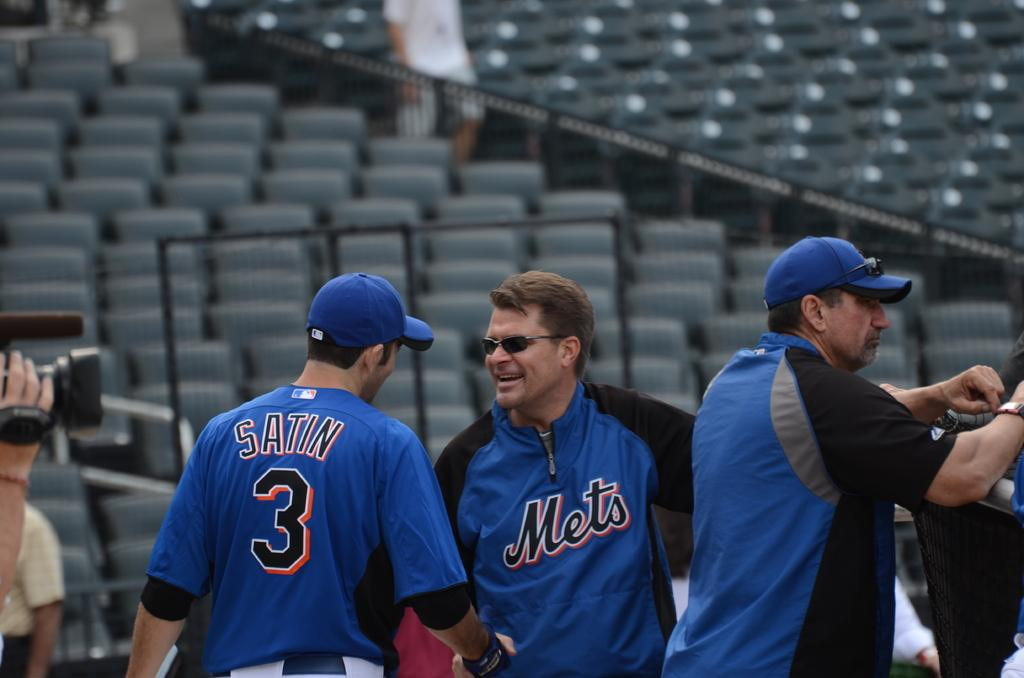<image>
Describe the image concisely. Players from the Mets baseball team at a stadium 